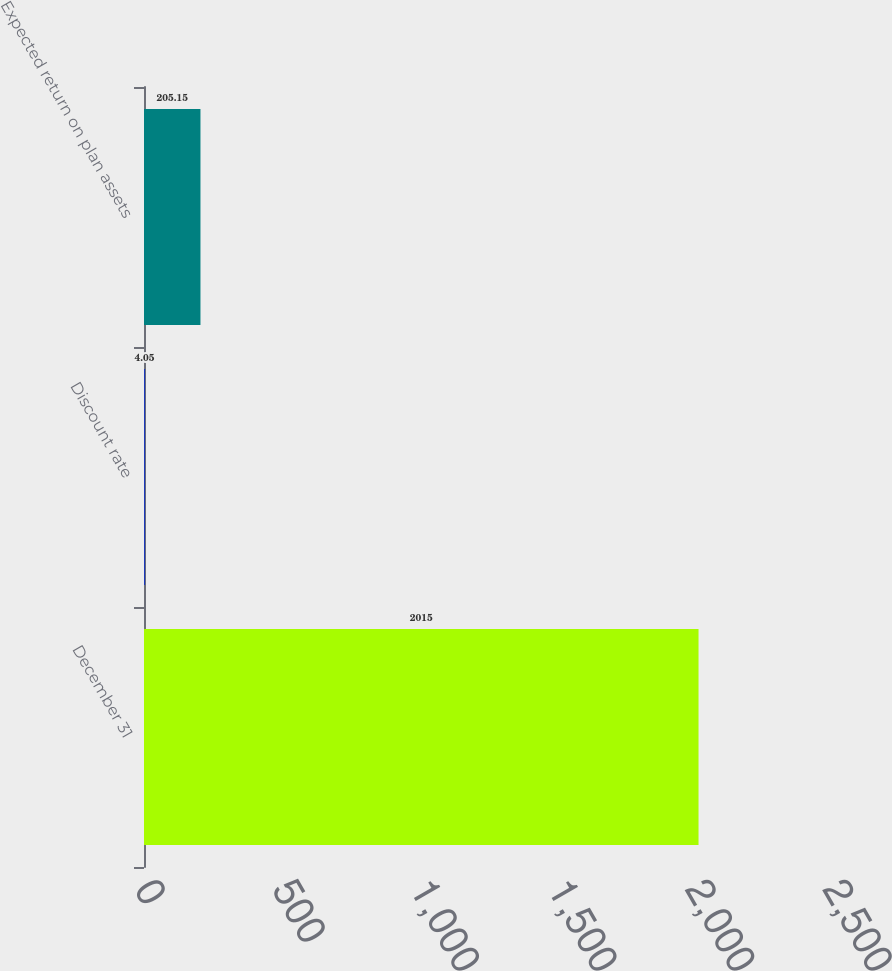Convert chart to OTSL. <chart><loc_0><loc_0><loc_500><loc_500><bar_chart><fcel>December 31<fcel>Discount rate<fcel>Expected return on plan assets<nl><fcel>2015<fcel>4.05<fcel>205.15<nl></chart> 